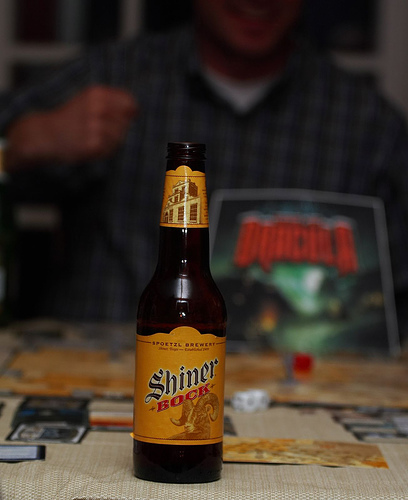<image>
Is the knuckle next to the table? Yes. The knuckle is positioned adjacent to the table, located nearby in the same general area. Where is the beer bottle in relation to the table cloth? Is it above the table cloth? No. The beer bottle is not positioned above the table cloth. The vertical arrangement shows a different relationship. 